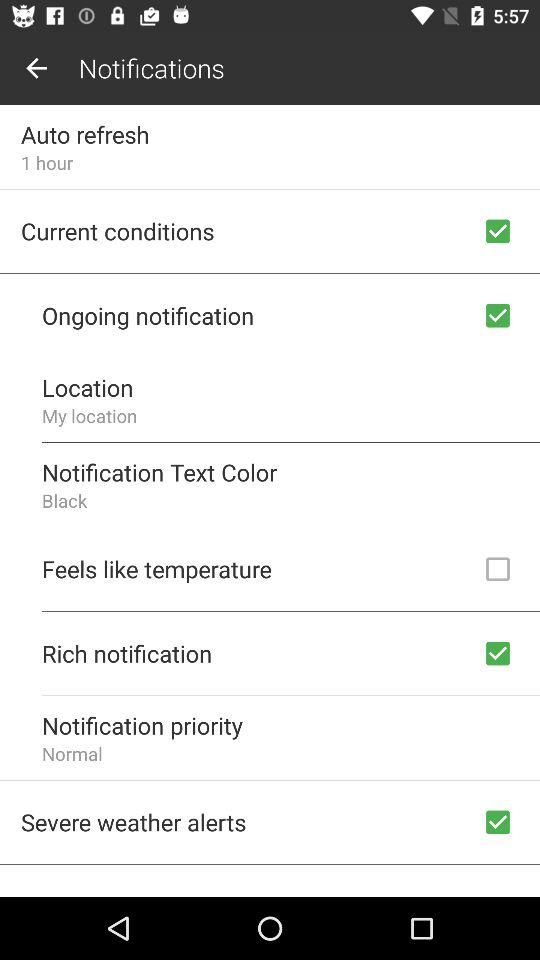Which notification setting is unchecked? The unchecked notification setting is "Feels like temperature". 